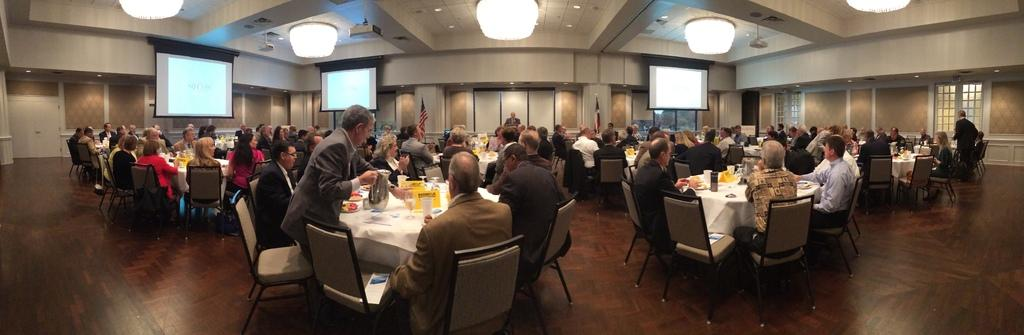How many people are in the image? There are people in the image, but the exact number is not specified. What are the people doing in the image? The people are sitting on a table and having a conversation. What might be the purpose of the people sitting on the table? The people might be having a meeting or gathering while sitting on the table. What type of coil can be seen wrapped around the table in the image? There is no coil present in the image. What color is the boot that one of the people is wearing in the image? There is no mention of boots or any footwear in the image. 